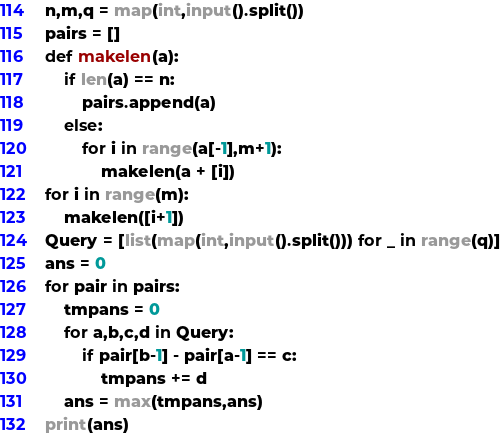Convert code to text. <code><loc_0><loc_0><loc_500><loc_500><_Python_>n,m,q = map(int,input().split())
pairs = []
def makelen(a):
    if len(a) == n:
        pairs.append(a)
    else:
        for i in range(a[-1],m+1):
            makelen(a + [i])
for i in range(m):
    makelen([i+1])
Query = [list(map(int,input().split())) for _ in range(q)]
ans = 0
for pair in pairs:
    tmpans = 0
    for a,b,c,d in Query:
        if pair[b-1] - pair[a-1] == c:
            tmpans += d
    ans = max(tmpans,ans)
print(ans)</code> 